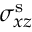Convert formula to latex. <formula><loc_0><loc_0><loc_500><loc_500>\sigma _ { x z } ^ { s }</formula> 